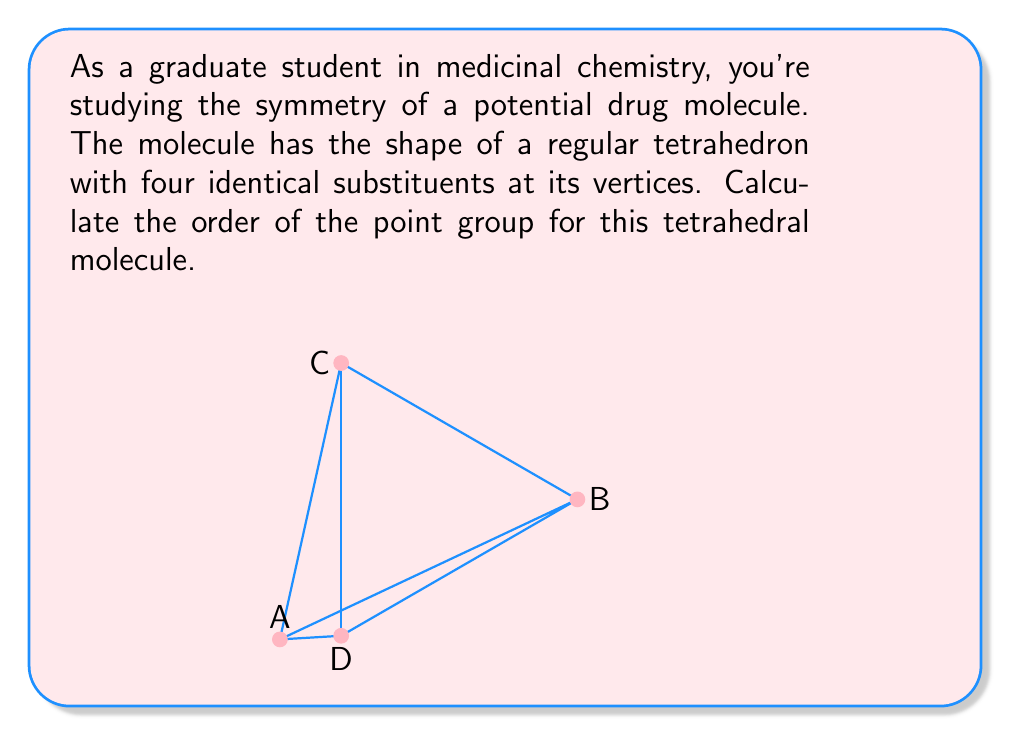Show me your answer to this math problem. To determine the order of the point group for a tetrahedral molecule, we need to count all symmetry operations:

1. Identity operation (E): Always present, count = 1

2. Proper rotations:
   - 4 C₃ axes (through each vertex): 3 rotations each, count = 4 × 2 = 8
   - 3 C₂ axes (through edge midpoints): 1 rotation each, count = 3 × 1 = 3

3. Improper rotations:
   - 3 S₄ axes (through edge midpoints): 3 rotations each, count = 3 × 3 = 9

4. Mirror planes:
   - 6 σd planes (through opposite edges): count = 6

Total symmetry operations:
$$ 1 + 8 + 3 + 9 + 6 = 27 $$

The order of the point group is equal to the total number of symmetry operations.

Note: This point group is known as $T_d$ (tetrahedral).
Answer: 27 